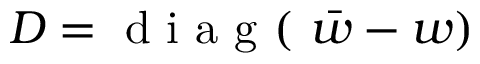<formula> <loc_0><loc_0><loc_500><loc_500>D = d i a g ( \bar { w } - w )</formula> 